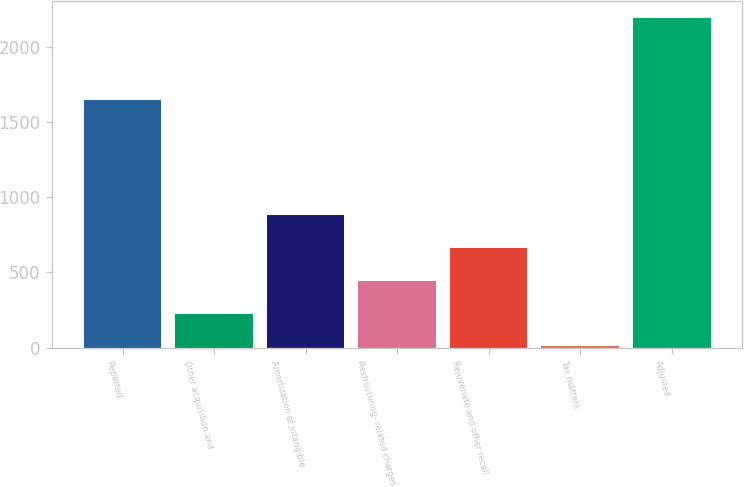Convert chart. <chart><loc_0><loc_0><loc_500><loc_500><bar_chart><fcel>Reported<fcel>Other acquisition and<fcel>Amortization of intangible<fcel>Restructuring- related charges<fcel>Rejuvenate and other recall<fcel>Tax matters<fcel>Adjusted<nl><fcel>1647<fcel>226.6<fcel>882.4<fcel>445.2<fcel>663.8<fcel>8<fcel>2194<nl></chart> 